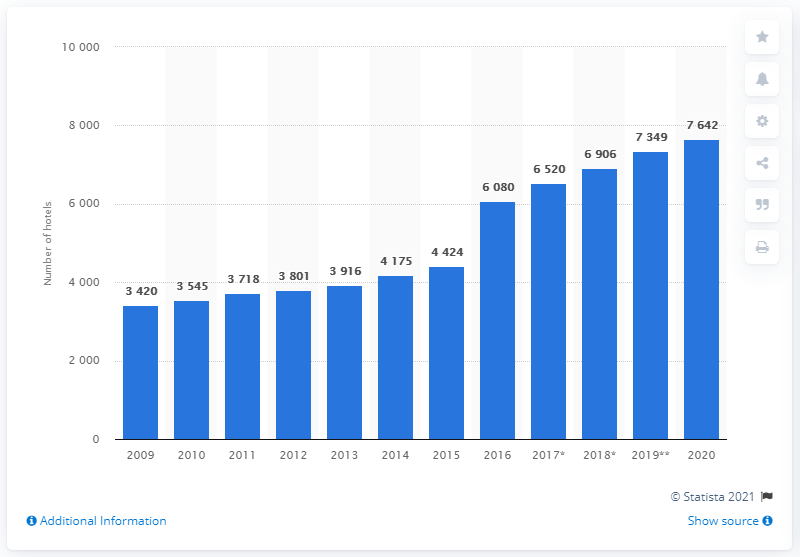Indicate a few pertinent items in this graphic. In 2015, Marriott acquired Delta Hotels and Starwood Hotels and Resorts. 